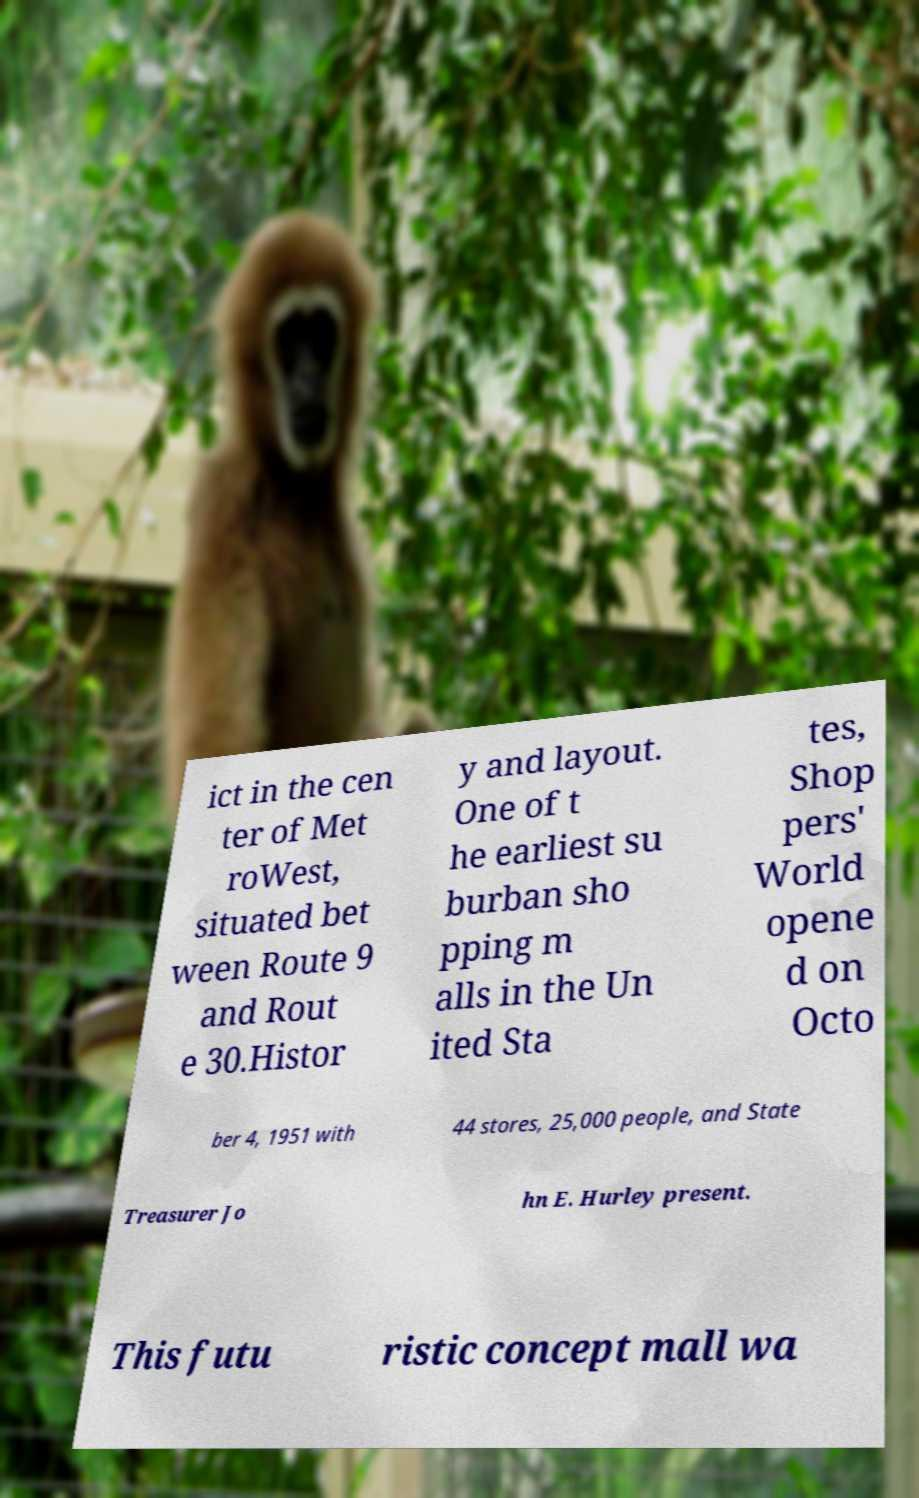Could you extract and type out the text from this image? ict in the cen ter of Met roWest, situated bet ween Route 9 and Rout e 30.Histor y and layout. One of t he earliest su burban sho pping m alls in the Un ited Sta tes, Shop pers' World opene d on Octo ber 4, 1951 with 44 stores, 25,000 people, and State Treasurer Jo hn E. Hurley present. This futu ristic concept mall wa 